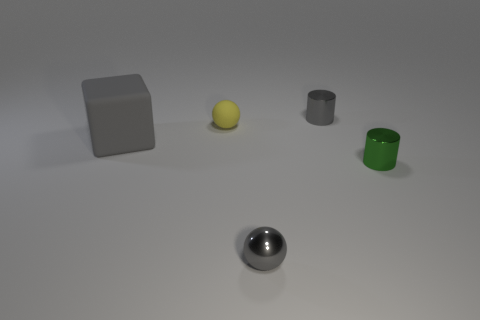What materials do the objects appear to be made of? The objects in the image seem to be made of different materials. The closest object appears to be a shiny metallic sphere, likely steel or polished chrome, while the two cylindrical objects seem to be made of matte materials, perhaps metal or plastic. The cube appears to be gray, matte, and possibly made of a stone-like or plastic material. The smaller sphere looks to be either plastic or rubber due to its less reflective, uniform surface. 